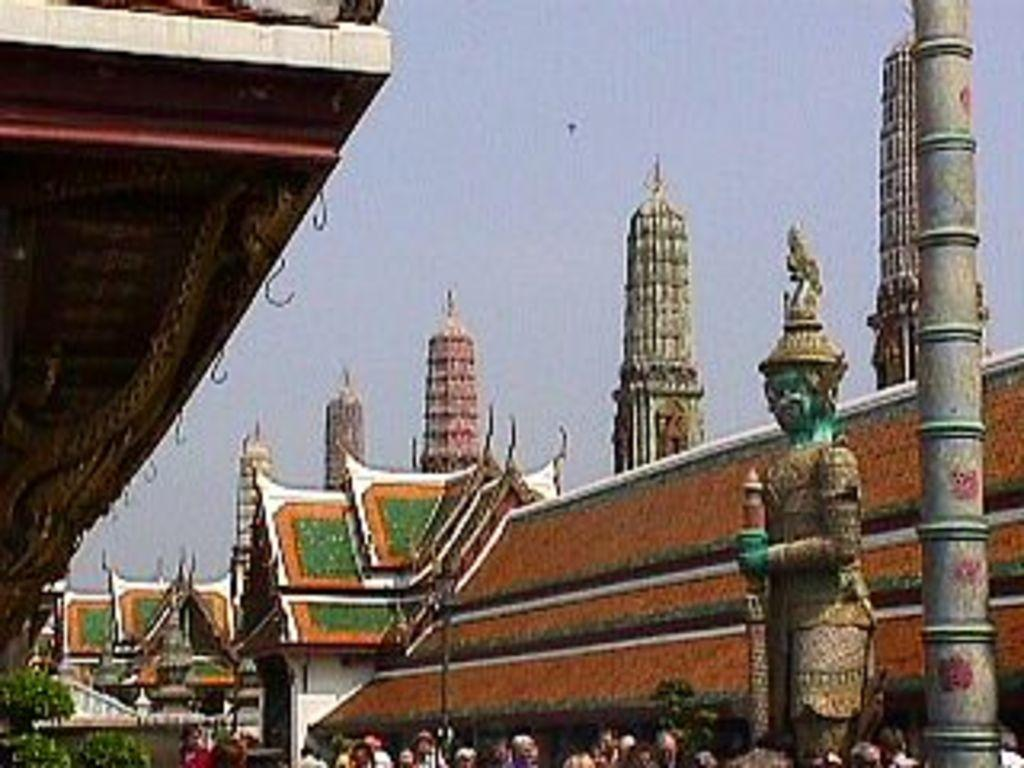What can be seen at the bottom of the image? There are people standing at the bottom of the image. What is the main object in the middle of the image? There is a statue in the image. What structures are located behind the statue? There are buildings behind the statue. What are the vertical structures in the image? There are poles in the image. What is visible at the top of the image? The sky is visible at the top of the image. Are there any people sleeping in the image? There is no indication of anyone sleeping in the image. How many balls can be seen in the image? There are no balls present in the image. 